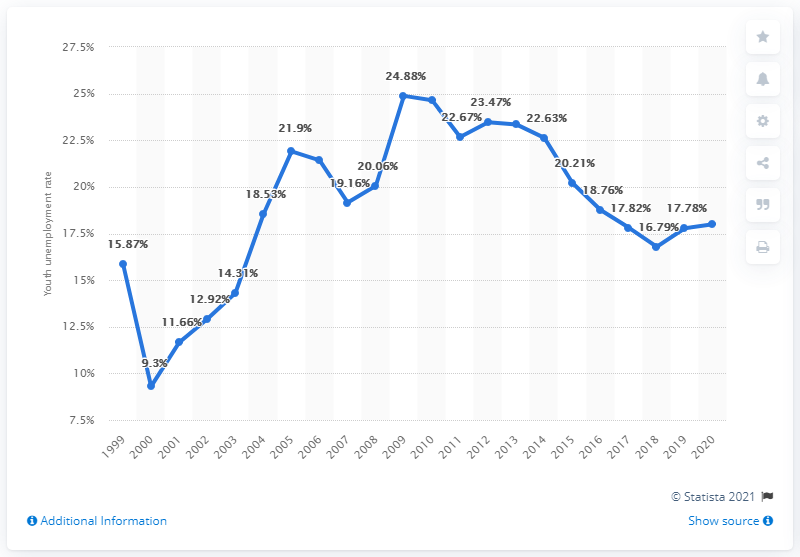List a handful of essential elements in this visual. The youth unemployment rate in Sweden in 2020 was 18%. 